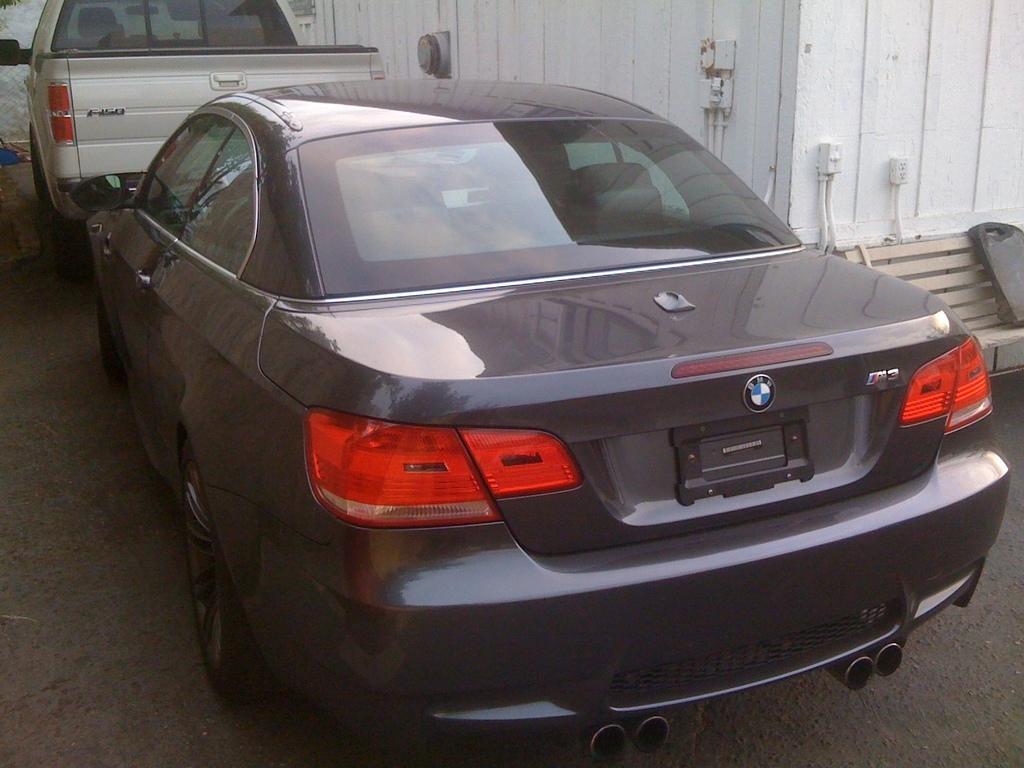Please provide a concise description of this image. In this image we can see vehicles on the ground and there are objects on the wall and we is an object on the bench on the right side. 